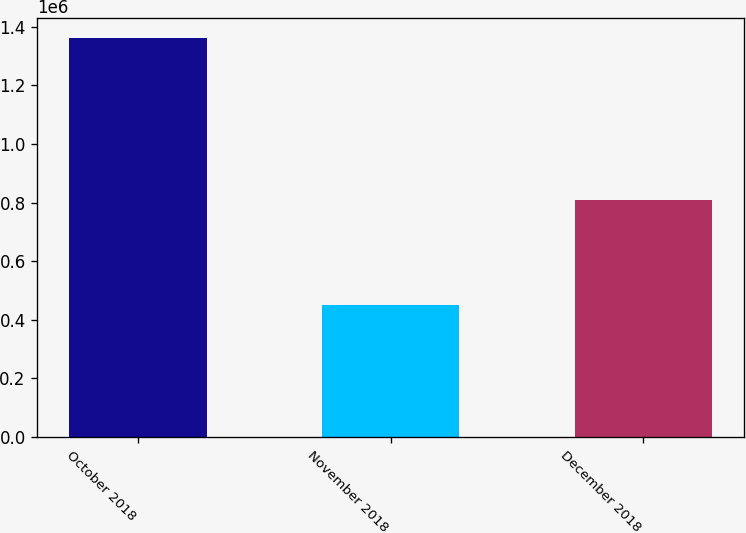<chart> <loc_0><loc_0><loc_500><loc_500><bar_chart><fcel>October 2018<fcel>November 2018<fcel>December 2018<nl><fcel>1.36099e+06<fcel>450000<fcel>810000<nl></chart> 